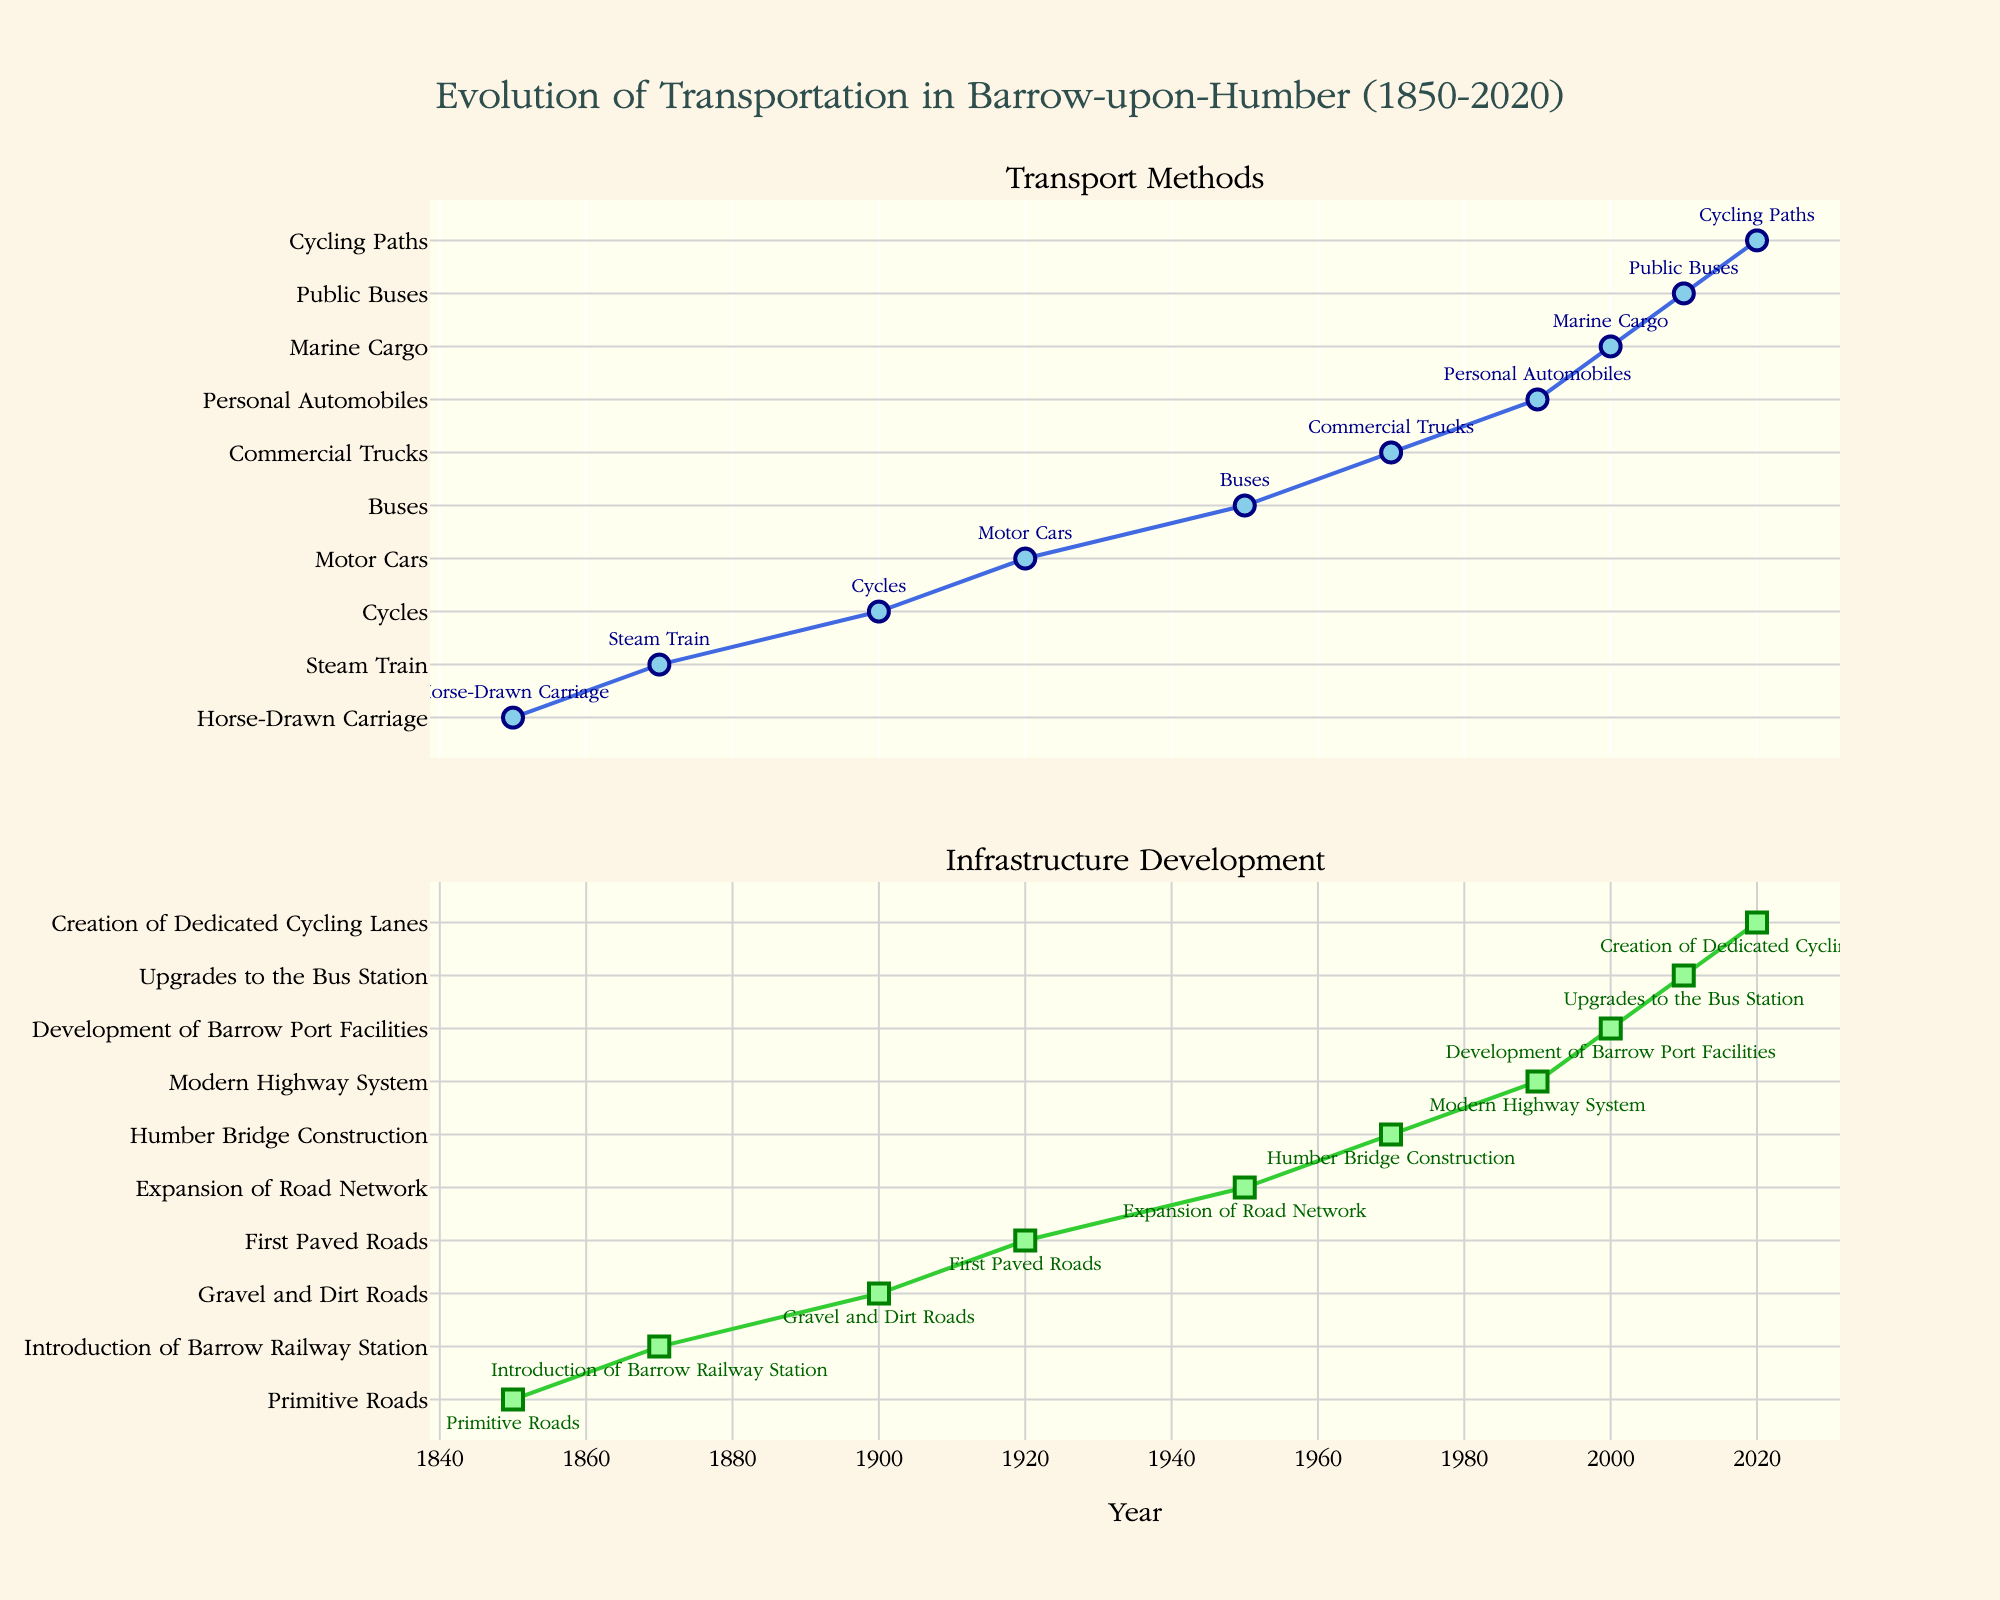What is the title of the figure? The title is located at the top of the figure, clearly readable in a larger font size.
Answer: Evolution of Transportation in Barrow-upon-Humber (1850-2020) What are the transport methods mentioned in 1870? The transport methods for each year can be identified by the markers and associated text labels in the upper subplot.
Answer: Steam Train Which year had the first introduction of paved roads? The infrastructure developments for each year are shown in the lower subplot, displayed via markers and text labels.
Answer: 1920 What significant infrastructure development occurred in 1970? By examining the lower subplot for the year 1970, we see the infrastructure development described.
Answer: Humber Bridge Construction Compare the transport method in 1900 with that in 2020. The transport methods in different years can be compared by referring to the markers and text labels in the upper subplot for the respective years.
Answer: Cycles and Cycling Paths How many years after the introduction of paving were personal automobiles noted as a transport method? Determine the year personal automobiles appeared, and subtract the year of the first paved roads. Personal automobiles were noted in 1990 and paved roads in 1920. The difference is calculated as 1990 - 1920 = 70.
Answer: 70 years What transport method was recorded in 1950 and what infrastructure development came with it? Check the markers and labels for the year 1950 in both upper and lower subplots to identify the transport method and the infrastructure development.
Answer: Buses and Expansion of Road Network Which came first, the development of Barrow Port Facilities or the introduction of Dedicated Cycling Lanes? Compare the years corresponding to these two developments by referring to the lower subplot and associated text labels.
Answer: Development of Barrow Port Facilities What is the most recent infrastructure development shown in the figure? The most recent year displayed in the lower subplot will indicate the latest infrastructure development.
Answer: Creation of Dedicated Cycling Lanes Was the introduction of the Steam Train or Motor Cars earlier? Compare the years for Steam Train and Motor Cars in the upper subplot to determine which came earlier.
Answer: Steam Train 